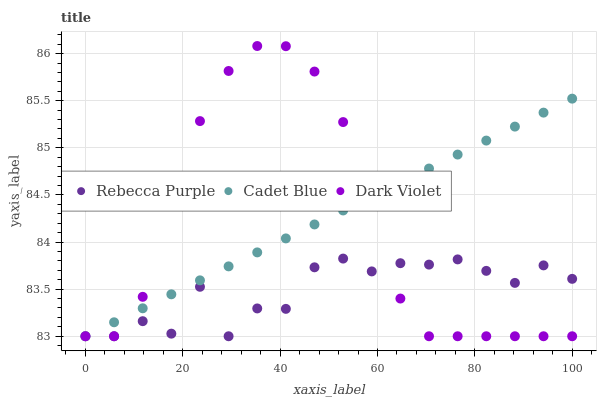Does Rebecca Purple have the minimum area under the curve?
Answer yes or no. Yes. Does Cadet Blue have the maximum area under the curve?
Answer yes or no. Yes. Does Dark Violet have the minimum area under the curve?
Answer yes or no. No. Does Dark Violet have the maximum area under the curve?
Answer yes or no. No. Is Cadet Blue the smoothest?
Answer yes or no. Yes. Is Rebecca Purple the roughest?
Answer yes or no. Yes. Is Dark Violet the smoothest?
Answer yes or no. No. Is Dark Violet the roughest?
Answer yes or no. No. Does Cadet Blue have the lowest value?
Answer yes or no. Yes. Does Dark Violet have the highest value?
Answer yes or no. Yes. Does Rebecca Purple have the highest value?
Answer yes or no. No. Does Cadet Blue intersect Dark Violet?
Answer yes or no. Yes. Is Cadet Blue less than Dark Violet?
Answer yes or no. No. Is Cadet Blue greater than Dark Violet?
Answer yes or no. No. 